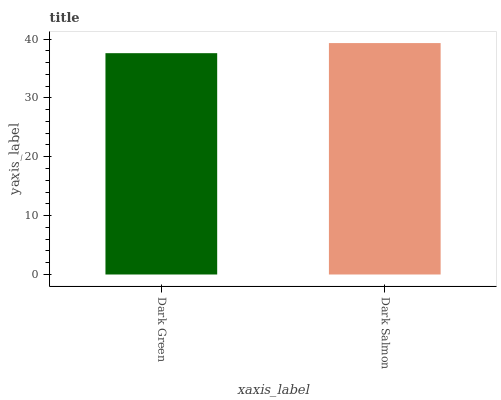Is Dark Green the minimum?
Answer yes or no. Yes. Is Dark Salmon the maximum?
Answer yes or no. Yes. Is Dark Salmon the minimum?
Answer yes or no. No. Is Dark Salmon greater than Dark Green?
Answer yes or no. Yes. Is Dark Green less than Dark Salmon?
Answer yes or no. Yes. Is Dark Green greater than Dark Salmon?
Answer yes or no. No. Is Dark Salmon less than Dark Green?
Answer yes or no. No. Is Dark Salmon the high median?
Answer yes or no. Yes. Is Dark Green the low median?
Answer yes or no. Yes. Is Dark Green the high median?
Answer yes or no. No. Is Dark Salmon the low median?
Answer yes or no. No. 